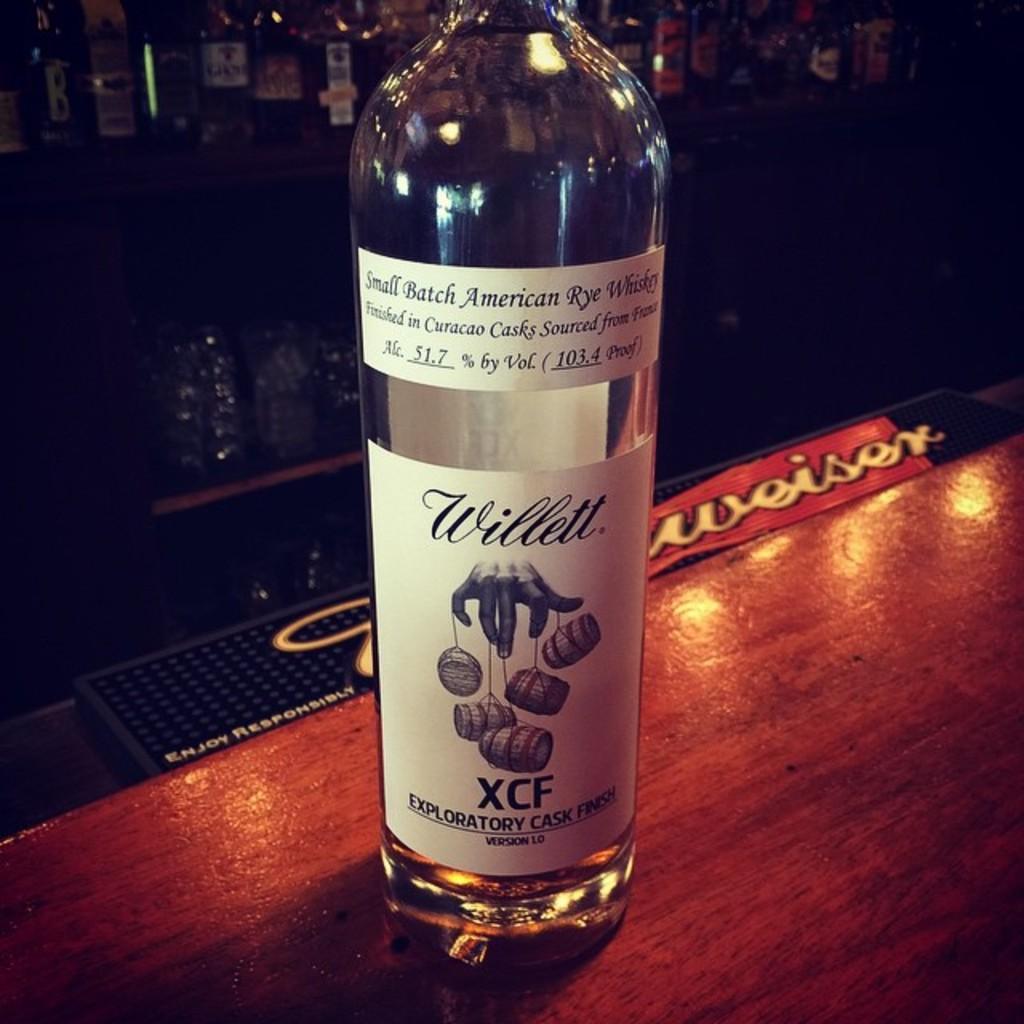What is the alcohol content?
Provide a short and direct response. 51.7%. 